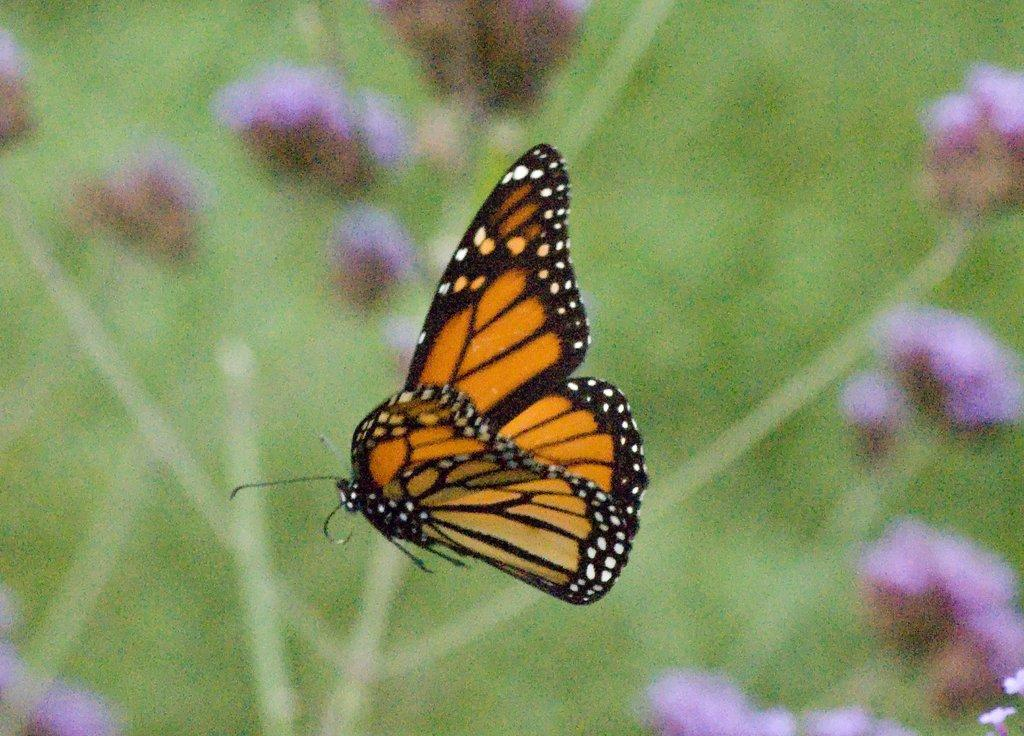What is the main subject of the image? There is a butterfly in the image. What can be seen in the background of the image? There is greenery and flowers in the background of the image. How many snails are crawling on the sugar in the image? There are no snails or sugar present in the image. 